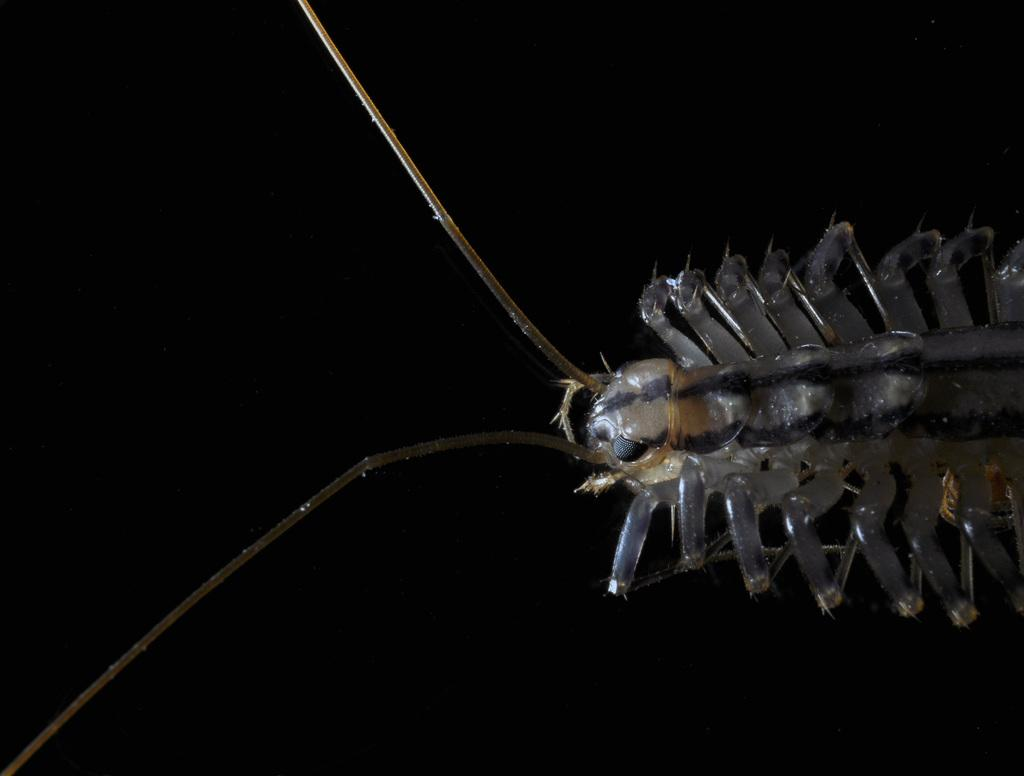What type of creature can be seen in the image? There is an insect in the picture. What is the color scheme of the background in the image? The background of the image is dark. Can you see any examples of ice in the image? There is no ice present in the image; it features an insect against a dark background. How many toes can be seen on the insect in the image? Insects do not have toes, and there are no other creatures or objects in the image that have toes. 